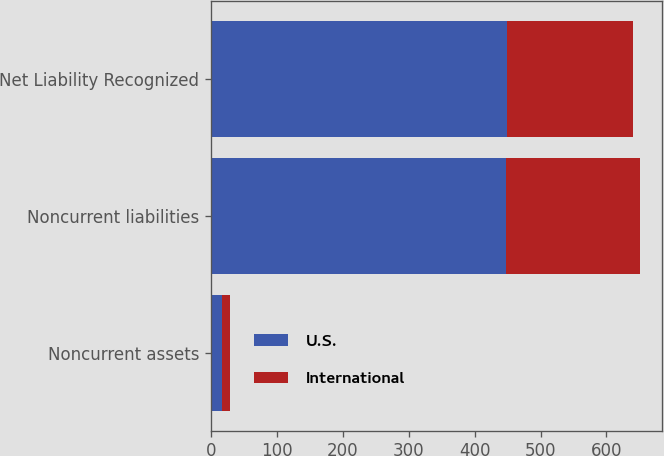Convert chart to OTSL. <chart><loc_0><loc_0><loc_500><loc_500><stacked_bar_chart><ecel><fcel>Noncurrent assets<fcel>Noncurrent liabilities<fcel>Net Liability Recognized<nl><fcel>U.S.<fcel>17.3<fcel>448.2<fcel>449.2<nl><fcel>International<fcel>11.4<fcel>203<fcel>191.6<nl></chart> 